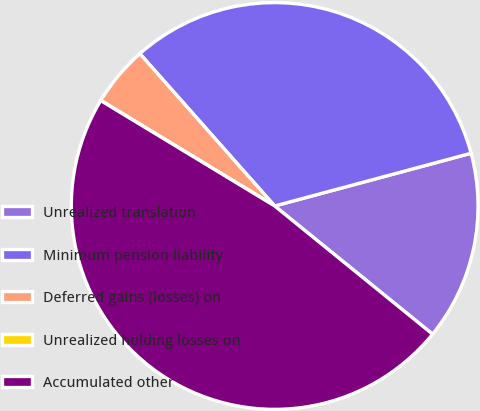Convert chart to OTSL. <chart><loc_0><loc_0><loc_500><loc_500><pie_chart><fcel>Unrealized translation<fcel>Minimum pension liability<fcel>Deferred gains (losses) on<fcel>Unrealized holding losses on<fcel>Accumulated other<nl><fcel>15.03%<fcel>32.36%<fcel>4.79%<fcel>0.01%<fcel>47.82%<nl></chart> 